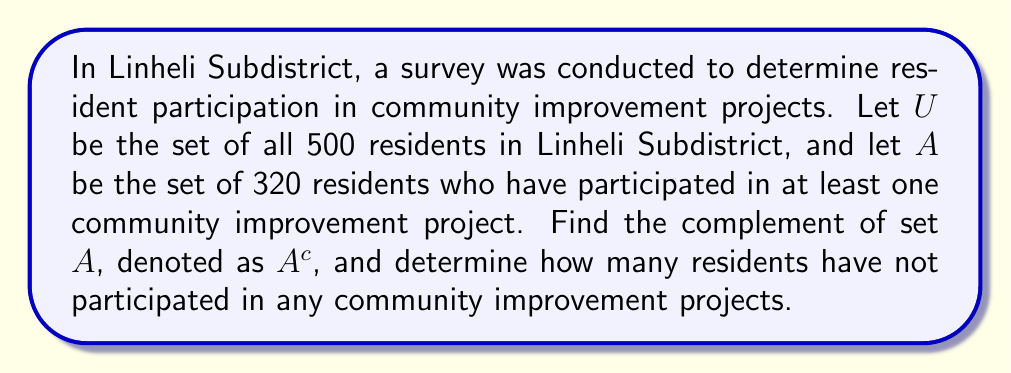Teach me how to tackle this problem. To solve this problem, we need to understand the concept of complement in set theory and apply it to the given information.

1. The universal set $U$ represents all residents in Linheli Subdistrict:
   $|U| = 500$

2. Set $A$ represents residents who have participated in community improvement projects:
   $|A| = 320$

3. The complement of set $A$, denoted as $A^c$, represents residents who have not participated in any community improvement projects.

4. To find $A^c$, we use the formula:
   $|A^c| = |U| - |A|$

5. Substituting the values:
   $|A^c| = 500 - 320 = 180$

Therefore, the complement of set $A$ contains 180 residents who have not participated in any community improvement projects.
Answer: $A^c = 180$ residents 